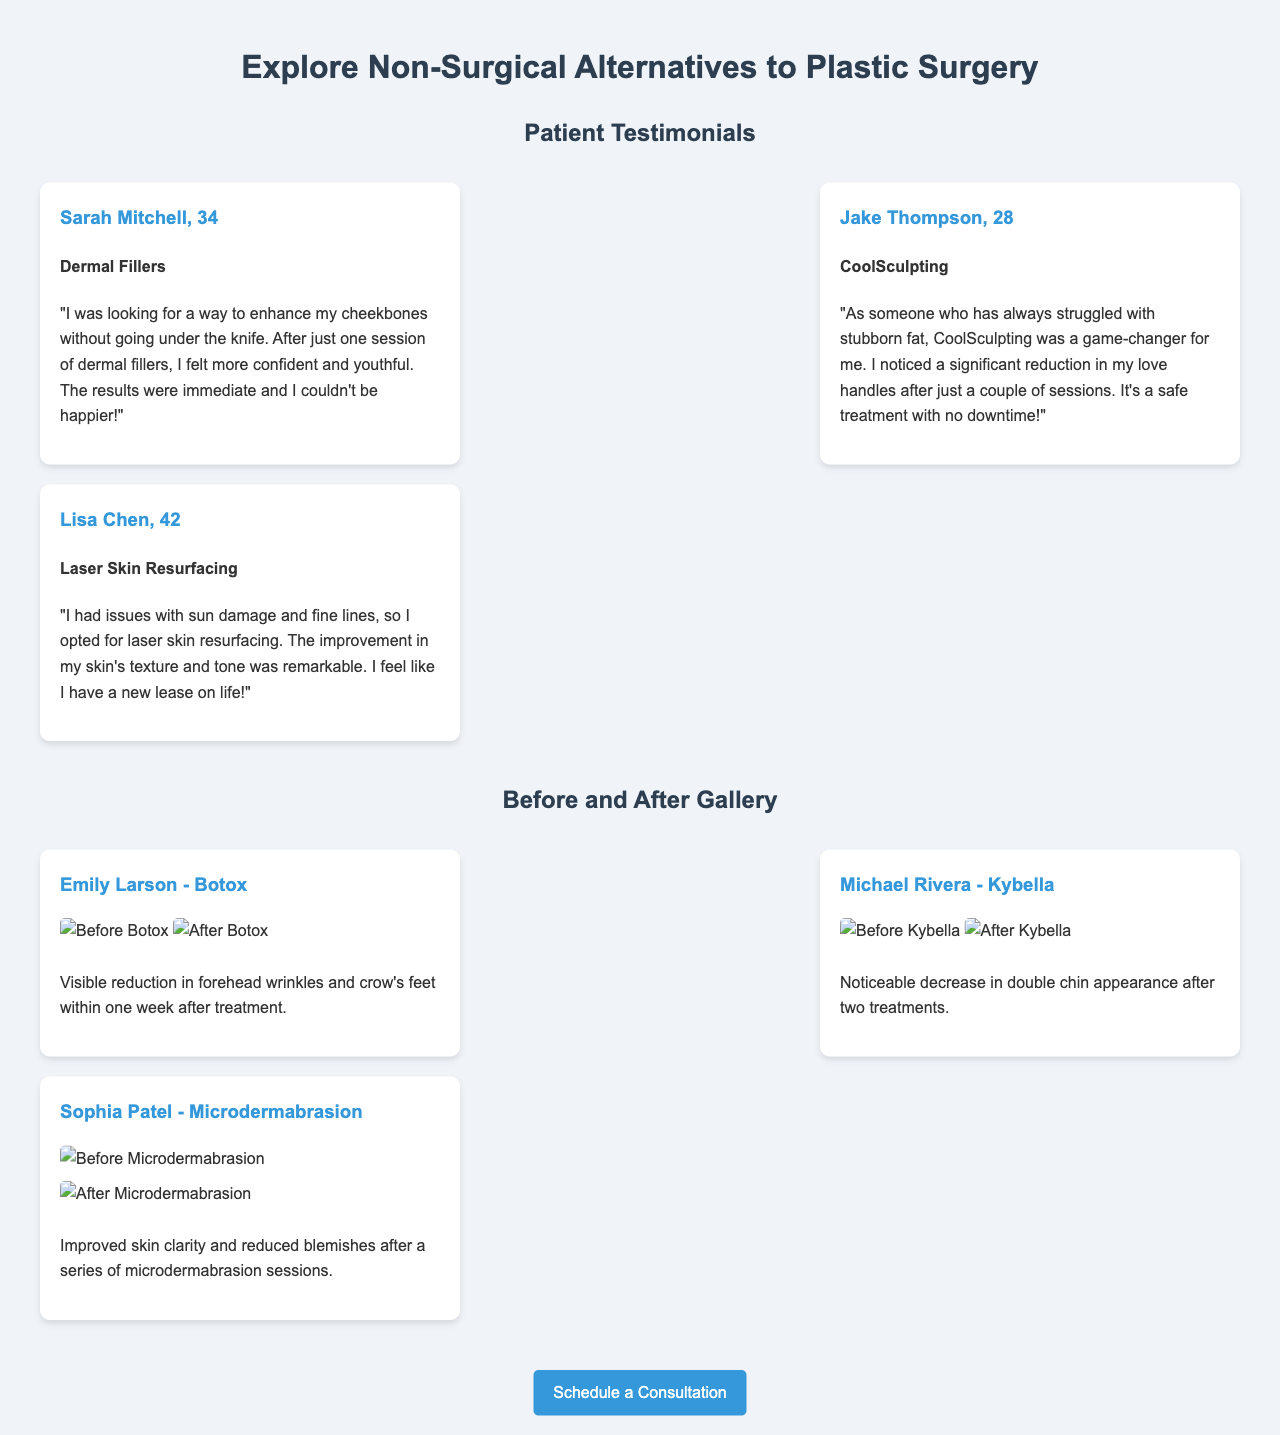What is the name of the testimonial provider for dermal fillers? Sarah Mitchell is the testimonial provider for dermal fillers.
Answer: Sarah Mitchell What age is Jake Thompson? Jake Thompson is 28 years old, as mentioned in his testimonial.
Answer: 28 What non-surgical treatment did Lisa Chen opt for? Lisa Chen opted for laser skin resurfacing as highlighted in her testimonial.
Answer: Laser skin resurfacing How many sessions did Emily Larson undergo for Botox? The document does not specify the number of sessions for Emily Larson, only that the results were visible within one week.
Answer: Not specified What improvement did Michael Rivera achieve with Kybella? Michael Rivera experienced a noticeable decrease in double chin appearance.
Answer: Decrease in double chin Which treatment is associated with Sophia Patel? Sophia Patel is associated with microdermabrasion in the before-and-after gallery.
Answer: Microdermabrasion What is the purpose of the "Schedule a Consultation" button? The button serves to allow users to schedule a consultation regarding non-surgical treatments.
Answer: Schedule a consultation What skin issue did Lisa Chen address with her treatment? Lisa Chen addressed sun damage and fine lines with her laser skin resurfacing treatment.
Answer: Sun damage and fine lines How long did it take for Emily Larson's treatment to show results? Emily Larson's treatment results were visible within one week after the Botox treatment.
Answer: One week 